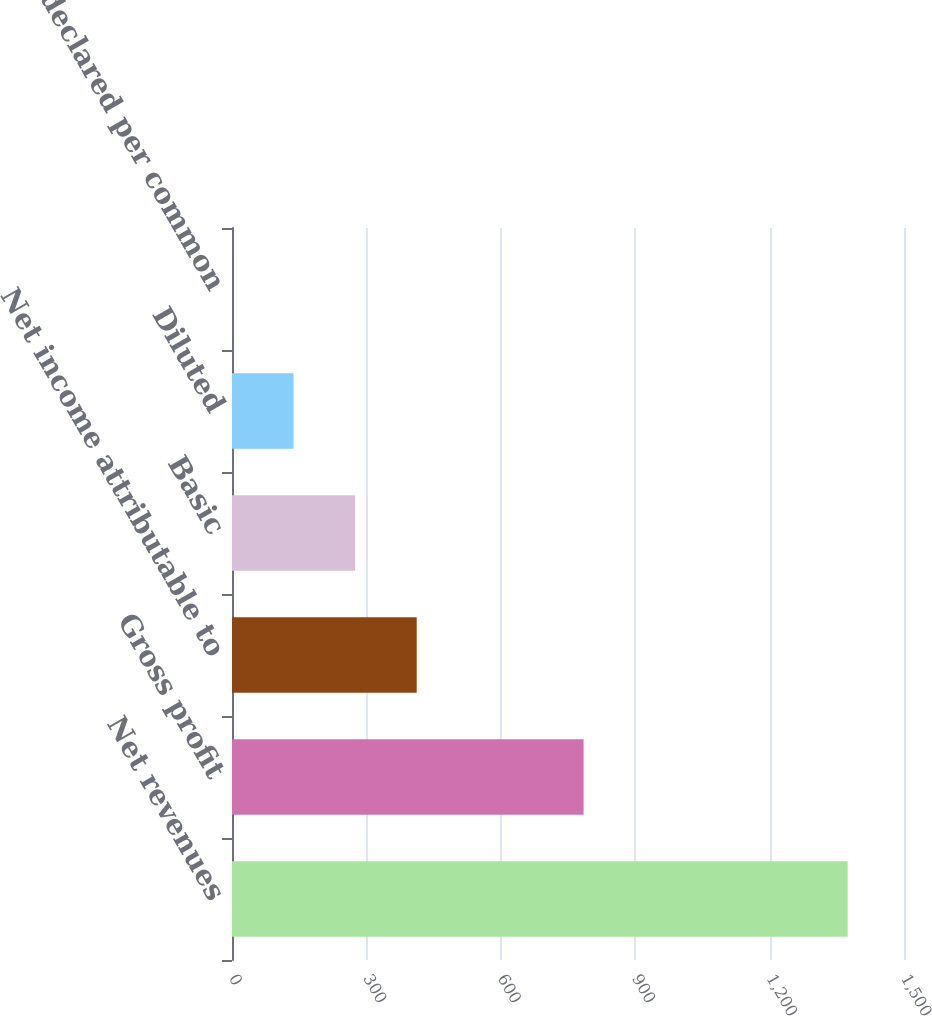Convert chart. <chart><loc_0><loc_0><loc_500><loc_500><bar_chart><fcel>Net revenues<fcel>Gross profit<fcel>Net income attributable to<fcel>Basic<fcel>Diluted<fcel>Dividends declared per common<nl><fcel>1374.2<fcel>784.8<fcel>412.3<fcel>274.88<fcel>137.47<fcel>0.05<nl></chart> 